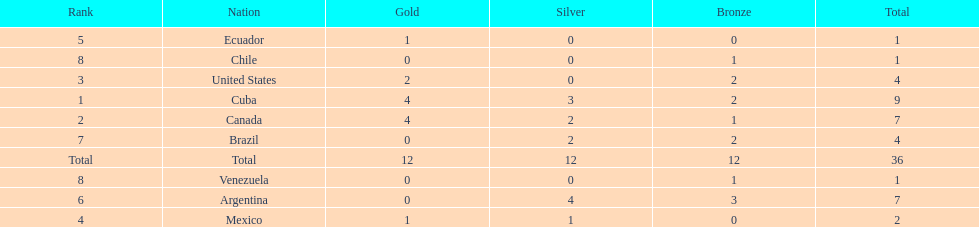Which country won the largest haul of bronze medals? Argentina. 